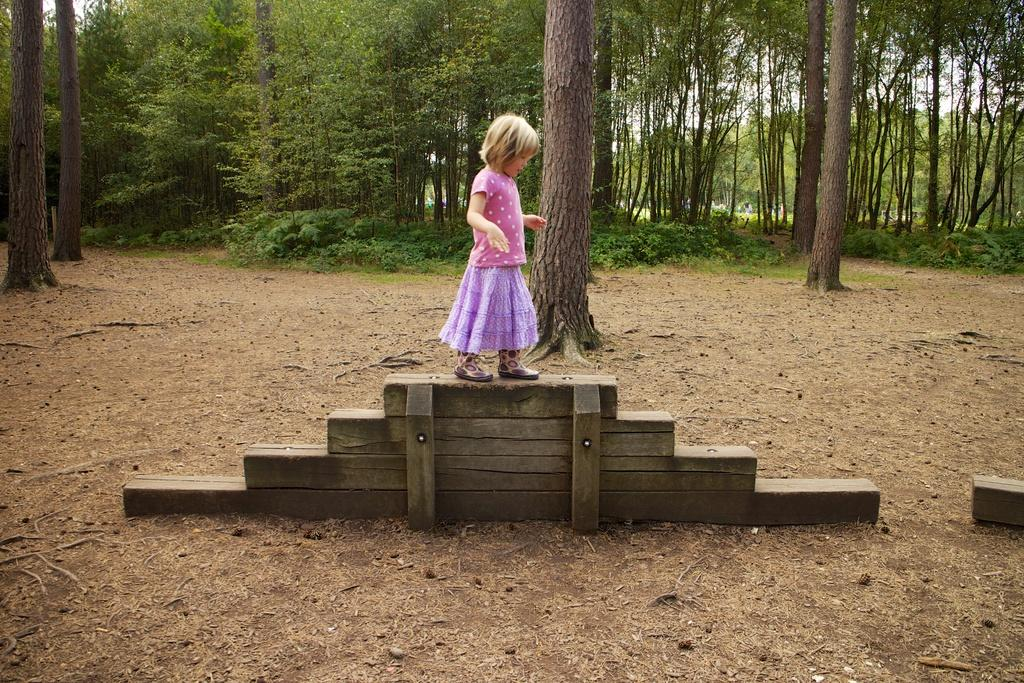Who is the main subject in the image? There is a girl in the image. What is the girl standing on? The girl is standing on wooden stairs. Where are the wooden stairs located? The wooden stairs are on the ground. What can be seen in the background of the image? There are many trees and some plants in the background of the image. What type of metal is the girl using to teach in the image? There is no metal or teaching activity present in the image. What kind of bun is the girl holding in the image? There is no bun present in the image. 